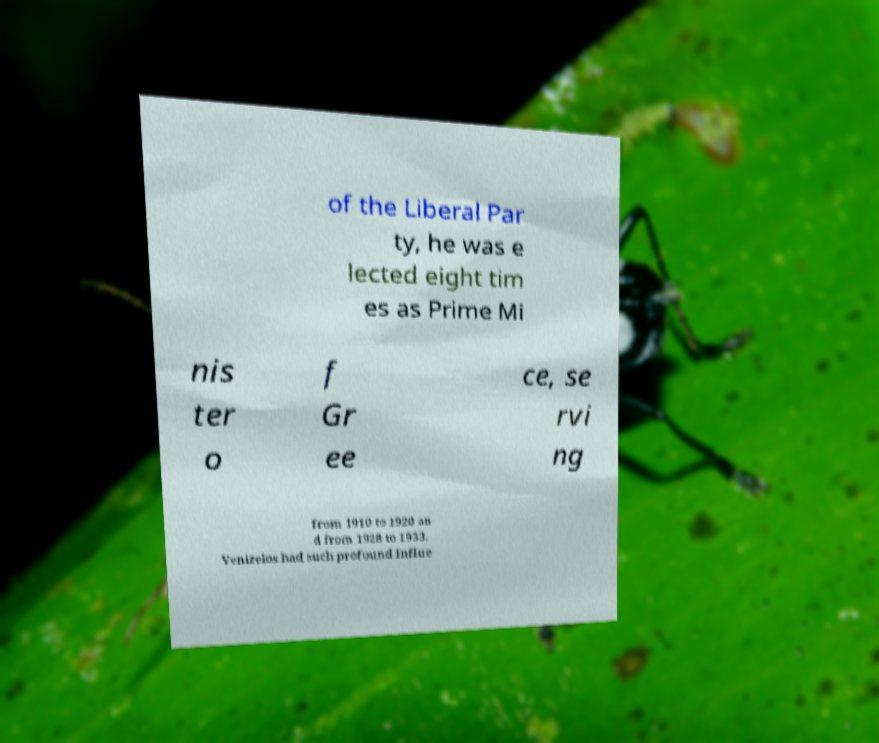I need the written content from this picture converted into text. Can you do that? of the Liberal Par ty, he was e lected eight tim es as Prime Mi nis ter o f Gr ee ce, se rvi ng from 1910 to 1920 an d from 1928 to 1933. Venizelos had such profound influe 